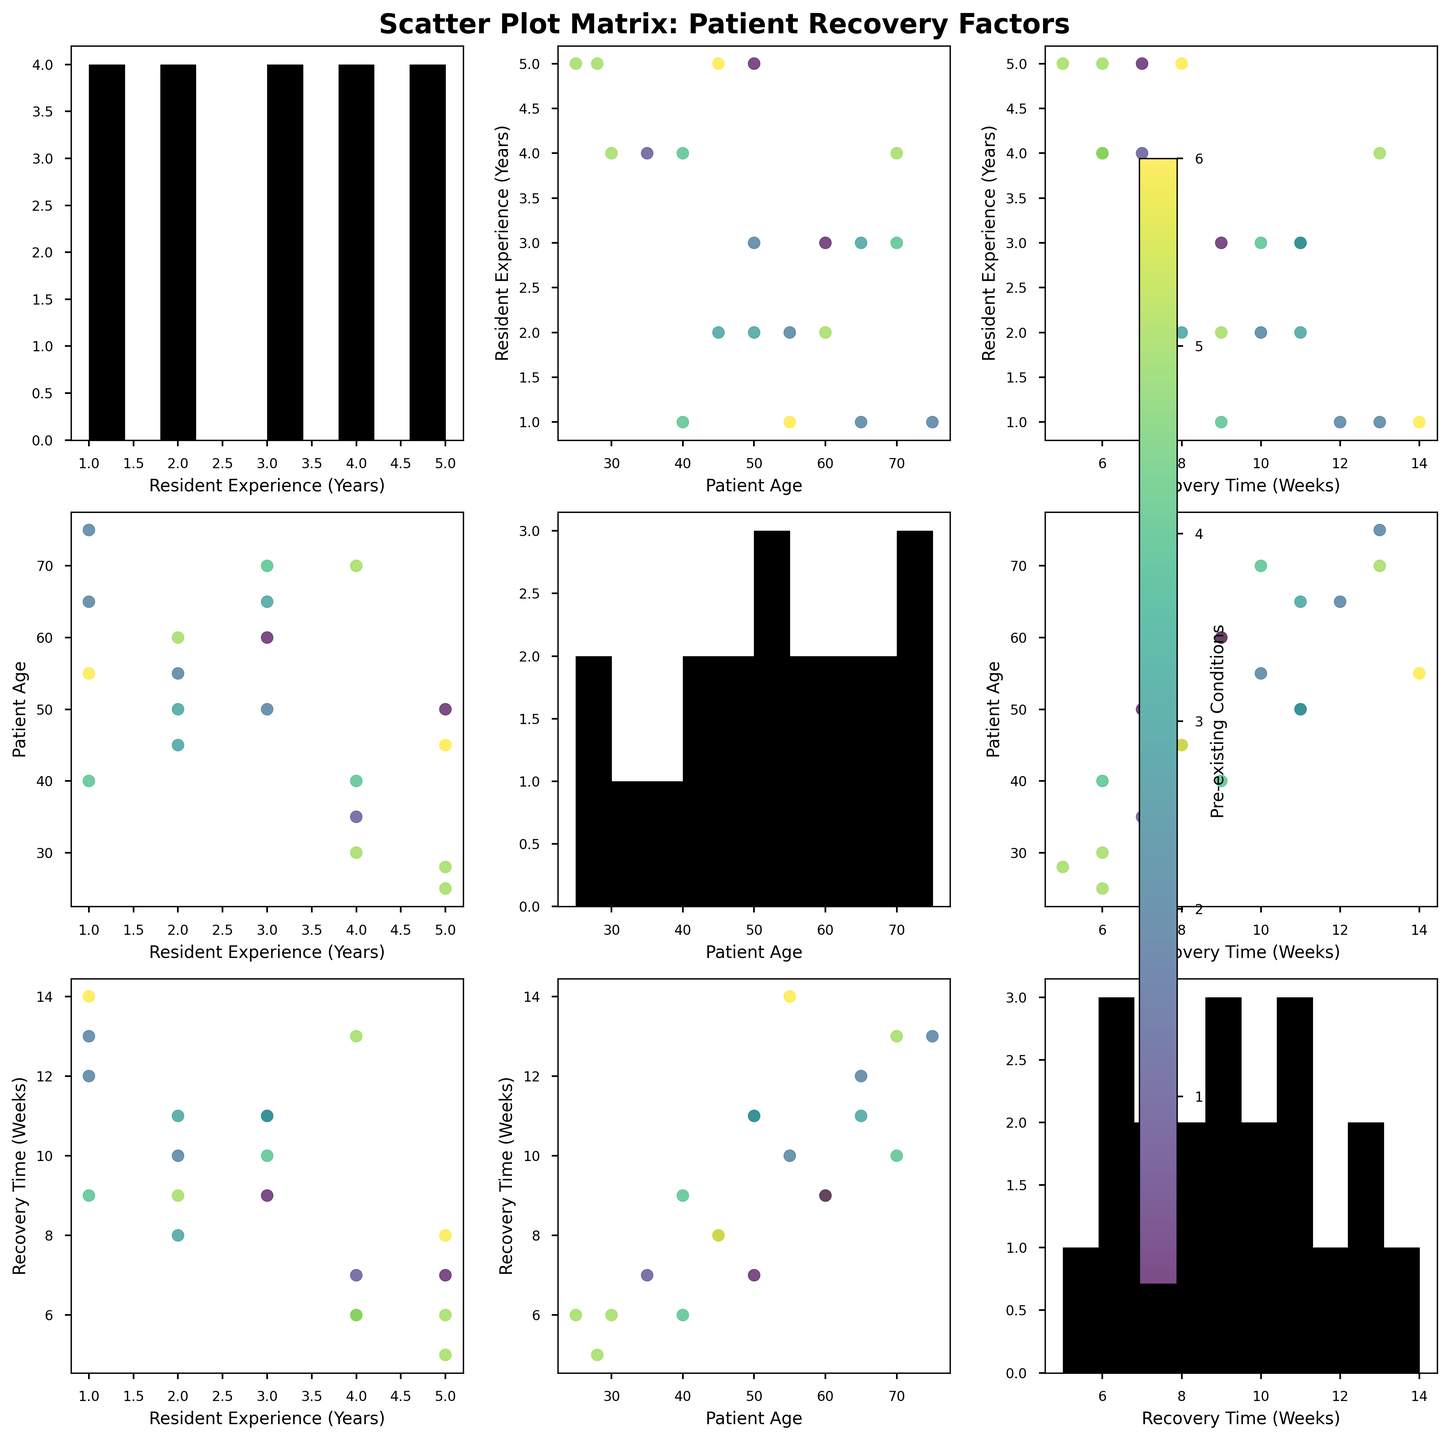How many data points are there in the scatter plot matrix? To determine the number of data points, we can count the total number of patient records used to generate the scatter plot matrix. Each patient ID represents one data point.
Answer: 20 What color represents patients with Diabetes in the scatter plot matrix? The scatter plot matrix uses different colors to represent pre-existing conditions. Checking the color bar legend on the side of the plot can help identify which color corresponds to Diabetes.
Answer: The specific color can be seen in the figure's colorbar What is the typical age range of patients who underwent ACL Reconstruction? Observing the 'Patient Age' axis in the scatter plot involving 'Type of Orthopedic Surgery' can give insights into the typical age range. Look specifically at the points labeled "ACL Reconstruction".
Answer: Typically between 25 and 40 years Is there a general trend between Resident Experience and Patient Recovery Time? By looking at the scatter plot where 'Resident Experience (Years)' is on the x-axis and 'Recovery Time (Weeks)' is on the y-axis, we can infer if there is an increasing or decreasing trend.
Answer: Generally, as Resident Experience increases, Recovery Time tends to decrease Which pre-existing condition seems to have the most variability in Patient Recovery Time? To identify this, observe the spread of different colors (representing different pre-existing conditions) in the 'Recovery Time (Weeks)' scatter plots. The condition with points spread over a broader range will have the most variability.
Answer: Diabetes Do younger patients tend to recover faster compared to older patients? Examine the scatter plot where 'Patient Age' is plotted against 'Recovery Time (Weeks)'. Look for a trend showing recovery times for younger patients versus older ones.
Answer: Younger patients tend to recover faster Is there any correlation between the Type of Orthopedic Surgery and Recovery Time? Check scatter plots involving 'Type of Orthopedic Surgery' and 'Recovery Time (Weeks)'. Patterns or clusters might indicate if certain surgeries generally correspond to certain recovery times.
Answer: There are patterns visible; for example, ACL Reconstruction tend to have shorter recovery times How does having no pre-existing conditions impact Recovery Time? Compare the points with 'None' as pre-existing conditions across the 'Recovery Time (Weeks)' scatter plots and see if they are generally lower or higher than those with conditions.
Answer: Generally, fewer recovery weeks What age group most frequently undergoes Shoulder Arthroscopy? Look at the scatter plots involving 'Type of Orthopedic Surgery' and 'Patient Age'. Identify the concentration of points for 'Shoulder Arthroscopy'.
Answer: Age 35-50 Do patients with Heart Disease show any specific recovery pattern based on age? Observe points on the scatter plots for 'Heart Disease' colored data, against 'Patient Age' and 'Recovery Time (Weeks)'. Look for any noticeable trends.
Answer: Older patients recover slower 